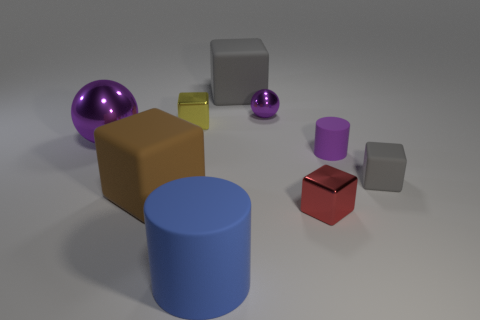The small yellow object that is the same material as the large purple sphere is what shape?
Offer a terse response. Cube. Is there any other thing of the same color as the large matte cylinder?
Give a very brief answer. No. What color is the sphere on the right side of the big blue rubber thing that is in front of the big brown thing?
Offer a very short reply. Purple. What number of big things are either matte cylinders or brown objects?
Ensure brevity in your answer.  2. What is the material of the other tiny object that is the same shape as the blue rubber object?
Your answer should be compact. Rubber. Are there any other things that are the same material as the tiny purple cylinder?
Provide a short and direct response. Yes. The tiny matte cube has what color?
Offer a terse response. Gray. Is the small rubber block the same color as the small metal ball?
Give a very brief answer. No. There is a matte cylinder that is left of the small red object; how many tiny shiny spheres are on the left side of it?
Your response must be concise. 0. There is a object that is both in front of the purple rubber thing and to the right of the red shiny cube; what is its size?
Provide a succinct answer. Small. 